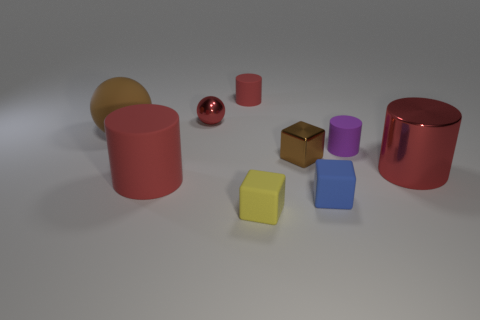There is a matte ball; is its size the same as the brown object that is right of the large red matte cylinder?
Offer a terse response. No. The big red cylinder on the left side of the matte cylinder that is behind the tiny purple cylinder is made of what material?
Your answer should be very brief. Rubber. Is the number of objects to the left of the small brown object the same as the number of small blue rubber cylinders?
Give a very brief answer. No. There is a red object that is both in front of the small red rubber cylinder and behind the large brown rubber ball; what size is it?
Your answer should be compact. Small. What is the color of the tiny block behind the large metallic cylinder that is right of the tiny red sphere?
Make the answer very short. Brown. How many yellow objects are spheres or tiny rubber cubes?
Provide a succinct answer. 1. There is a rubber cylinder that is both behind the tiny metallic cube and in front of the tiny ball; what is its color?
Keep it short and to the point. Purple. What number of big things are either purple rubber objects or purple metallic cylinders?
Your response must be concise. 0. There is another purple thing that is the same shape as the big metal thing; what is its size?
Keep it short and to the point. Small. What is the shape of the large red shiny thing?
Your answer should be compact. Cylinder. 